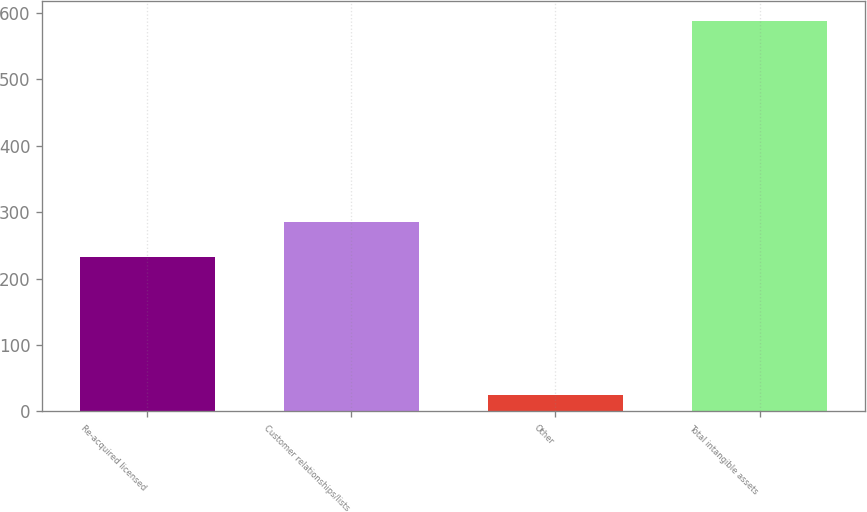Convert chart to OTSL. <chart><loc_0><loc_0><loc_500><loc_500><bar_chart><fcel>Re-acquired licensed<fcel>Customer relationships/lists<fcel>Other<fcel>Total intangible assets<nl><fcel>233.2<fcel>285.26<fcel>24.4<fcel>588.26<nl></chart> 